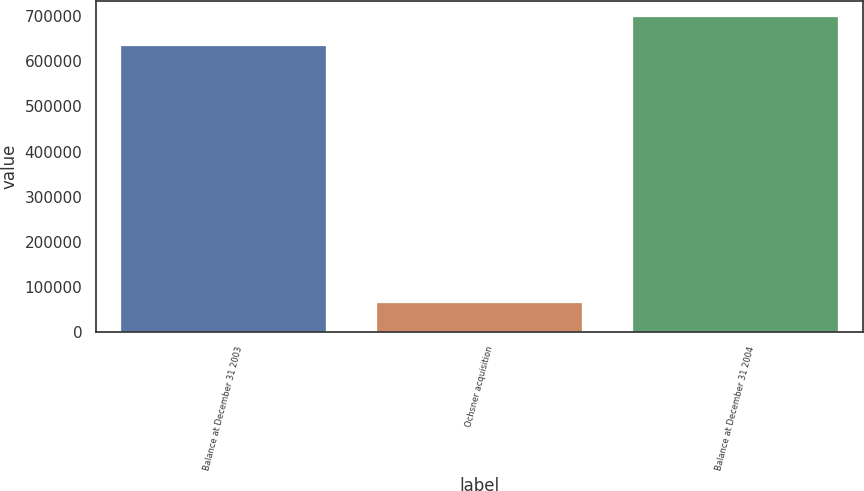<chart> <loc_0><loc_0><loc_500><loc_500><bar_chart><fcel>Balance at December 31 2003<fcel>Ochsner acquisition<fcel>Balance at December 31 2004<nl><fcel>633211<fcel>65219<fcel>698430<nl></chart> 